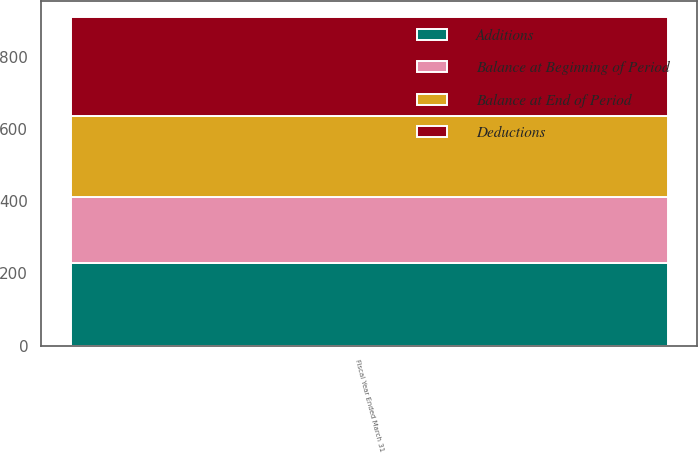<chart> <loc_0><loc_0><loc_500><loc_500><stacked_bar_chart><ecel><fcel>Fiscal Year Ended March 31<nl><fcel>Deductions<fcel>274<nl><fcel>Balance at Beginning of Period<fcel>181<nl><fcel>Balance at End of Period<fcel>225<nl><fcel>Additions<fcel>230<nl></chart> 